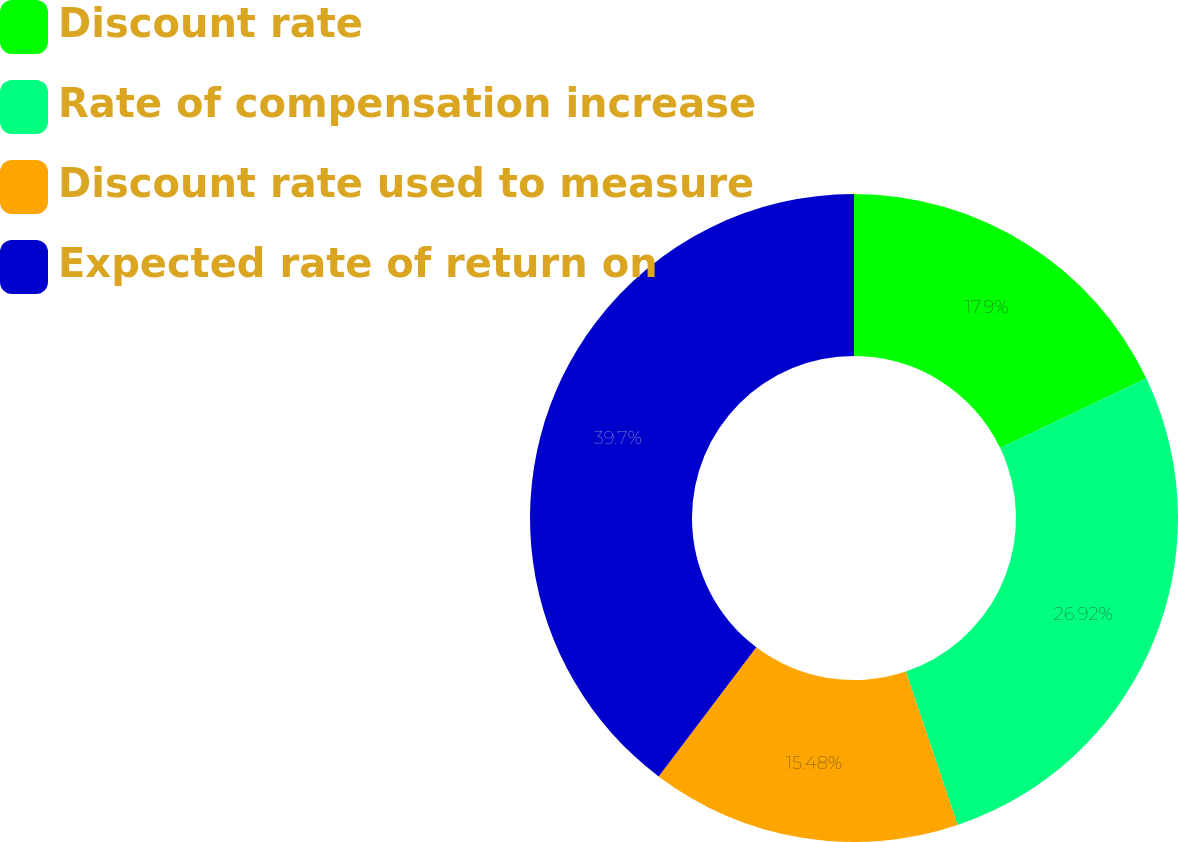Convert chart. <chart><loc_0><loc_0><loc_500><loc_500><pie_chart><fcel>Discount rate<fcel>Rate of compensation increase<fcel>Discount rate used to measure<fcel>Expected rate of return on<nl><fcel>17.9%<fcel>26.92%<fcel>15.48%<fcel>39.7%<nl></chart> 